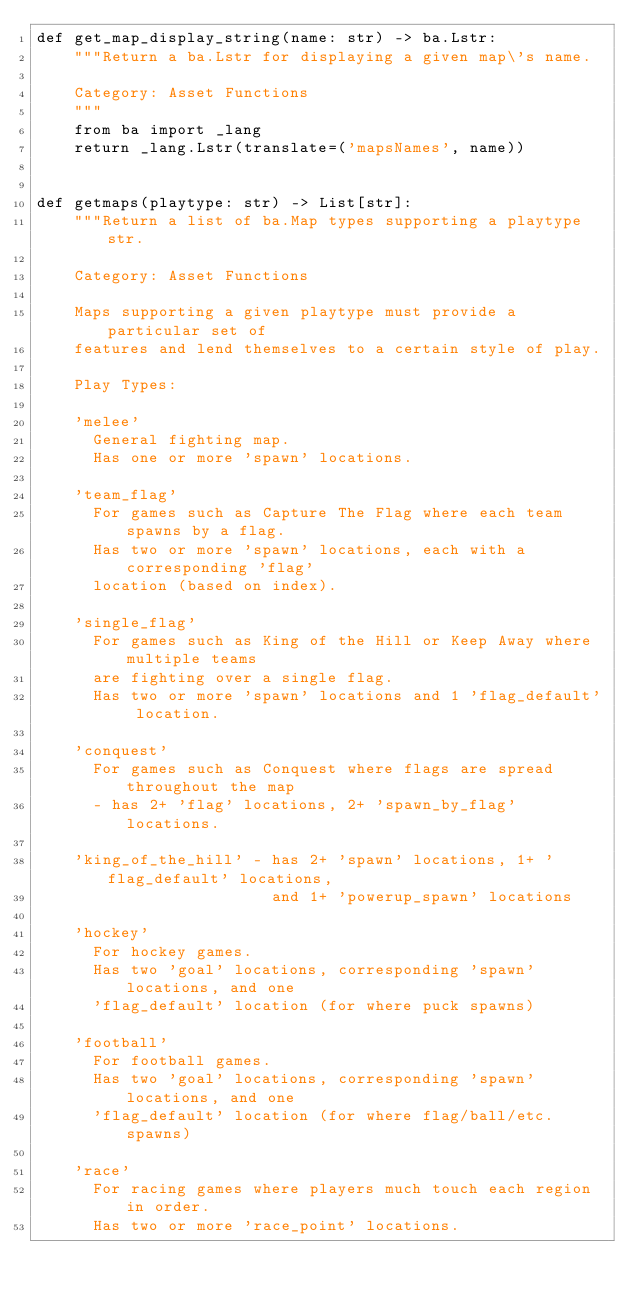<code> <loc_0><loc_0><loc_500><loc_500><_Python_>def get_map_display_string(name: str) -> ba.Lstr:
    """Return a ba.Lstr for displaying a given map\'s name.

    Category: Asset Functions
    """
    from ba import _lang
    return _lang.Lstr(translate=('mapsNames', name))


def getmaps(playtype: str) -> List[str]:
    """Return a list of ba.Map types supporting a playtype str.

    Category: Asset Functions

    Maps supporting a given playtype must provide a particular set of
    features and lend themselves to a certain style of play.

    Play Types:

    'melee'
      General fighting map.
      Has one or more 'spawn' locations.

    'team_flag'
      For games such as Capture The Flag where each team spawns by a flag.
      Has two or more 'spawn' locations, each with a corresponding 'flag'
      location (based on index).

    'single_flag'
      For games such as King of the Hill or Keep Away where multiple teams
      are fighting over a single flag.
      Has two or more 'spawn' locations and 1 'flag_default' location.

    'conquest'
      For games such as Conquest where flags are spread throughout the map
      - has 2+ 'flag' locations, 2+ 'spawn_by_flag' locations.

    'king_of_the_hill' - has 2+ 'spawn' locations, 1+ 'flag_default' locations,
                         and 1+ 'powerup_spawn' locations

    'hockey'
      For hockey games.
      Has two 'goal' locations, corresponding 'spawn' locations, and one
      'flag_default' location (for where puck spawns)

    'football'
      For football games.
      Has two 'goal' locations, corresponding 'spawn' locations, and one
      'flag_default' location (for where flag/ball/etc. spawns)

    'race'
      For racing games where players much touch each region in order.
      Has two or more 'race_point' locations.</code> 